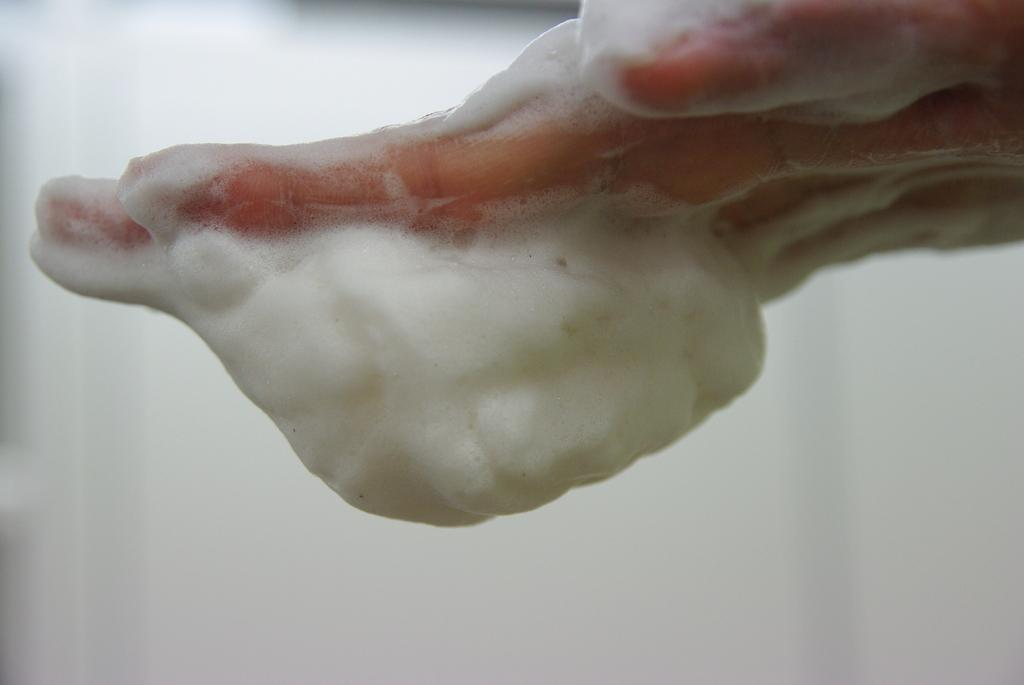What part of a person's body is visible in the image? There is a person's hand in the image. What is on the hand in the image? The hand has soap foam on it. What color is the background of the image? The background of the image is white. How many sheep are visible in the image? There are no sheep present in the image; it features a person's hand with soap foam on it against a white background. What type of trouble is the person experiencing in the image? There is no indication of trouble in the image; it simply shows a person's hand with soap foam on it against a white background. 